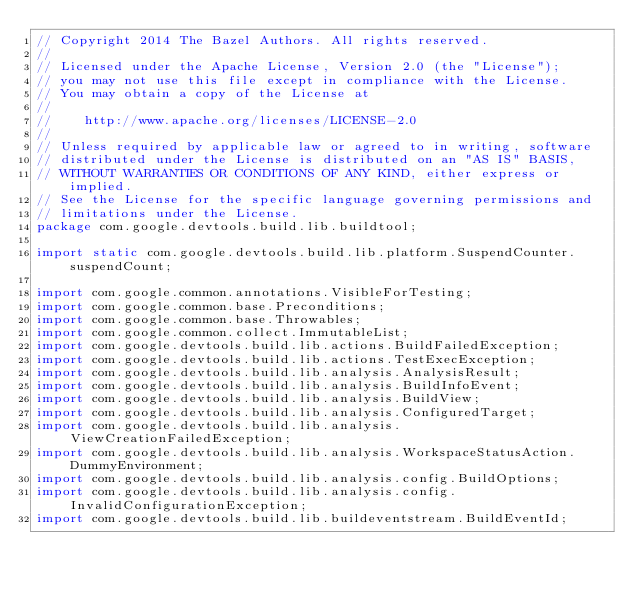<code> <loc_0><loc_0><loc_500><loc_500><_Java_>// Copyright 2014 The Bazel Authors. All rights reserved.
//
// Licensed under the Apache License, Version 2.0 (the "License");
// you may not use this file except in compliance with the License.
// You may obtain a copy of the License at
//
//    http://www.apache.org/licenses/LICENSE-2.0
//
// Unless required by applicable law or agreed to in writing, software
// distributed under the License is distributed on an "AS IS" BASIS,
// WITHOUT WARRANTIES OR CONDITIONS OF ANY KIND, either express or implied.
// See the License for the specific language governing permissions and
// limitations under the License.
package com.google.devtools.build.lib.buildtool;

import static com.google.devtools.build.lib.platform.SuspendCounter.suspendCount;

import com.google.common.annotations.VisibleForTesting;
import com.google.common.base.Preconditions;
import com.google.common.base.Throwables;
import com.google.common.collect.ImmutableList;
import com.google.devtools.build.lib.actions.BuildFailedException;
import com.google.devtools.build.lib.actions.TestExecException;
import com.google.devtools.build.lib.analysis.AnalysisResult;
import com.google.devtools.build.lib.analysis.BuildInfoEvent;
import com.google.devtools.build.lib.analysis.BuildView;
import com.google.devtools.build.lib.analysis.ConfiguredTarget;
import com.google.devtools.build.lib.analysis.ViewCreationFailedException;
import com.google.devtools.build.lib.analysis.WorkspaceStatusAction.DummyEnvironment;
import com.google.devtools.build.lib.analysis.config.BuildOptions;
import com.google.devtools.build.lib.analysis.config.InvalidConfigurationException;
import com.google.devtools.build.lib.buildeventstream.BuildEventId;</code> 